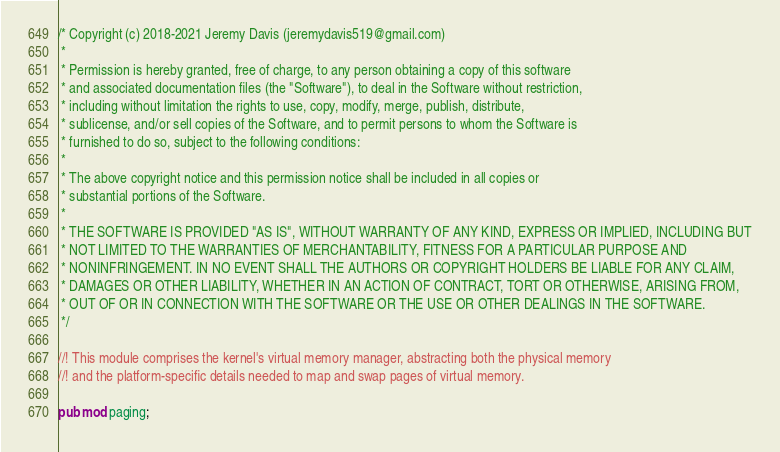<code> <loc_0><loc_0><loc_500><loc_500><_Rust_>/* Copyright (c) 2018-2021 Jeremy Davis (jeremydavis519@gmail.com)
 *
 * Permission is hereby granted, free of charge, to any person obtaining a copy of this software
 * and associated documentation files (the "Software"), to deal in the Software without restriction,
 * including without limitation the rights to use, copy, modify, merge, publish, distribute,
 * sublicense, and/or sell copies of the Software, and to permit persons to whom the Software is
 * furnished to do so, subject to the following conditions:
 *
 * The above copyright notice and this permission notice shall be included in all copies or
 * substantial portions of the Software.
 *
 * THE SOFTWARE IS PROVIDED "AS IS", WITHOUT WARRANTY OF ANY KIND, EXPRESS OR IMPLIED, INCLUDING BUT
 * NOT LIMITED TO THE WARRANTIES OF MERCHANTABILITY, FITNESS FOR A PARTICULAR PURPOSE AND
 * NONINFRINGEMENT. IN NO EVENT SHALL THE AUTHORS OR COPYRIGHT HOLDERS BE LIABLE FOR ANY CLAIM,
 * DAMAGES OR OTHER LIABILITY, WHETHER IN AN ACTION OF CONTRACT, TORT OR OTHERWISE, ARISING FROM,
 * OUT OF OR IN CONNECTION WITH THE SOFTWARE OR THE USE OR OTHER DEALINGS IN THE SOFTWARE.
 */

//! This module comprises the kernel's virtual memory manager, abstracting both the physical memory
//! and the platform-specific details needed to map and swap pages of virtual memory.

pub mod paging;
</code> 